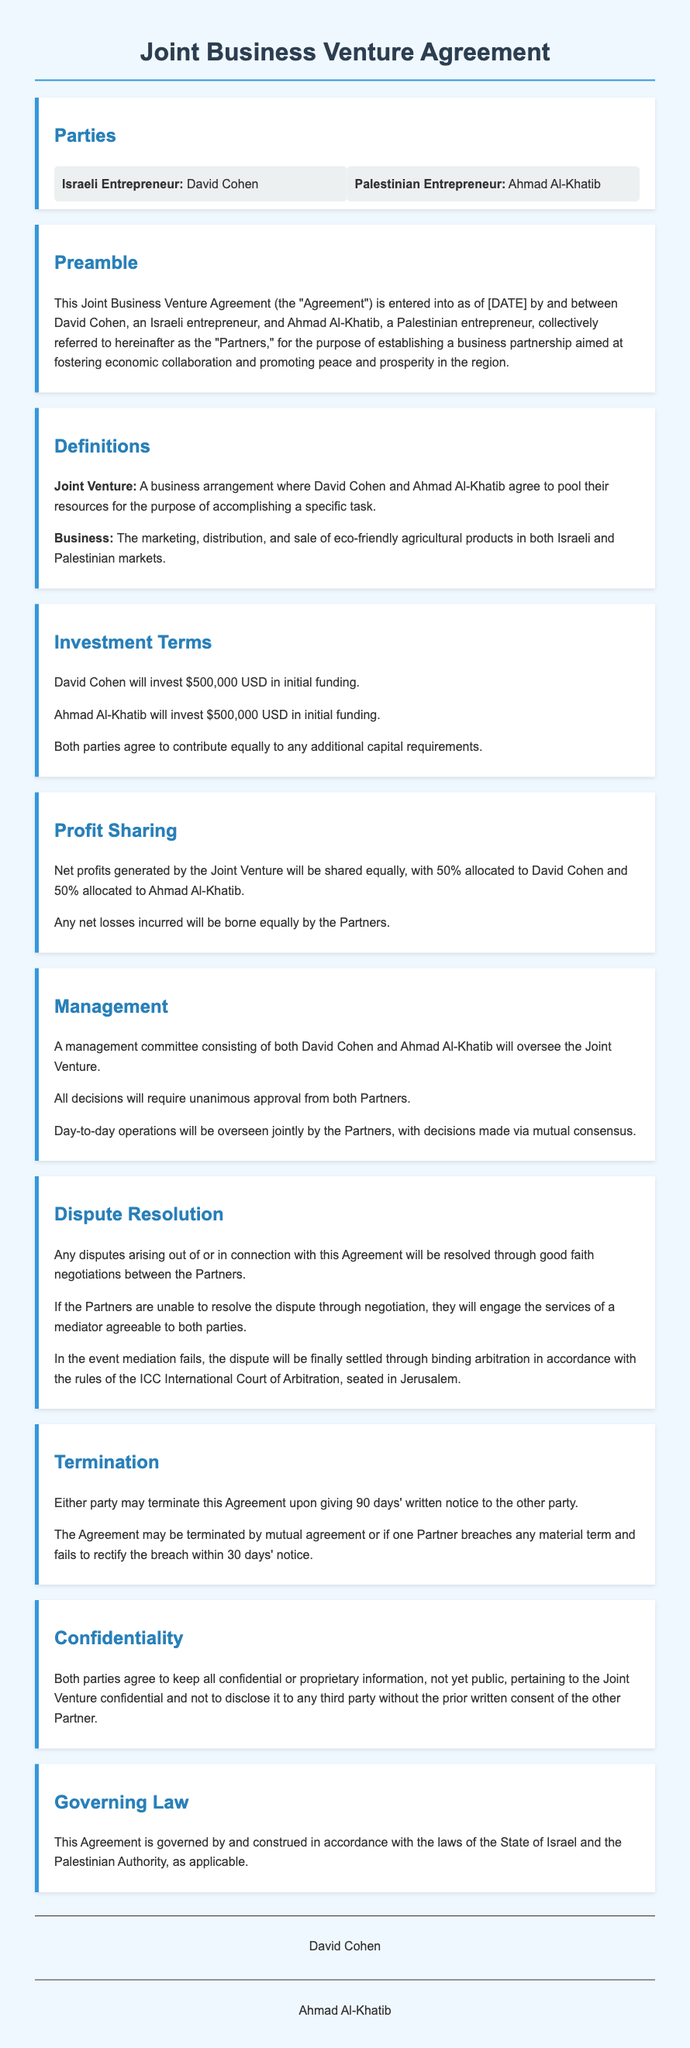What is the total amount invested by each partner? The total investment by each partner is specified under Investment Terms, which is $500,000 USD for both David Cohen and Ahmad Al-Khatib.
Answer: $500,000 USD Who are the parties involved in the agreement? The parties involved in the agreement are listed in the Parties section, including David Cohen and Ahmad Al-Khatib.
Answer: David Cohen and Ahmad Al-Khatib What is the primary purpose of the Joint Venture? The primary purpose of the Joint Venture is outlined in the Preamble, which emphasizes fostering economic collaboration and promoting peace and prosperity.
Answer: Fostering economic collaboration and promoting peace and prosperity How will profits be shared between the partners? The profit-sharing arrangement is described in the Profit Sharing section, stating that net profits will be shared equally between the two partners.
Answer: 50% each What mechanism is stipulated for dispute resolution? The dispute resolution process is outlined, specifying that disputes will be resolved through negotiation, mediation, and potentially arbitration.
Answer: Negotiation, mediation, and arbitration What is the written notice period required for termination? The termination provisions state that a written notice period of 90 days is required from either party to terminate the Agreement.
Answer: 90 days What are the governing laws mentioned in the agreement? The Governing Law section indicates that the Agreement is governed by the laws of the State of Israel and the Palestinian Authority.
Answer: State of Israel and Palestinian Authority 